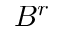<formula> <loc_0><loc_0><loc_500><loc_500>B ^ { r }</formula> 